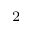Convert formula to latex. <formula><loc_0><loc_0><loc_500><loc_500>_ { 2 }</formula> 